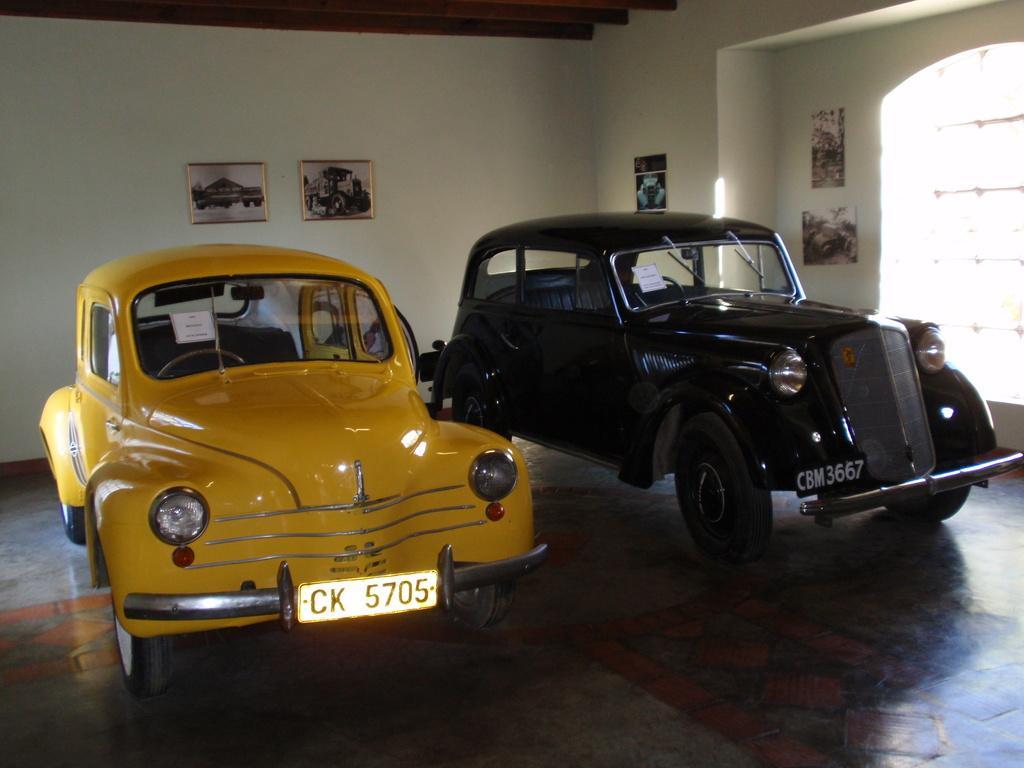Could you give a brief overview of what you see in this image? In the image we can see there are two cars parked on the ground and the cars are in yellow and black colour. Behind there are photo frames on the wall. 